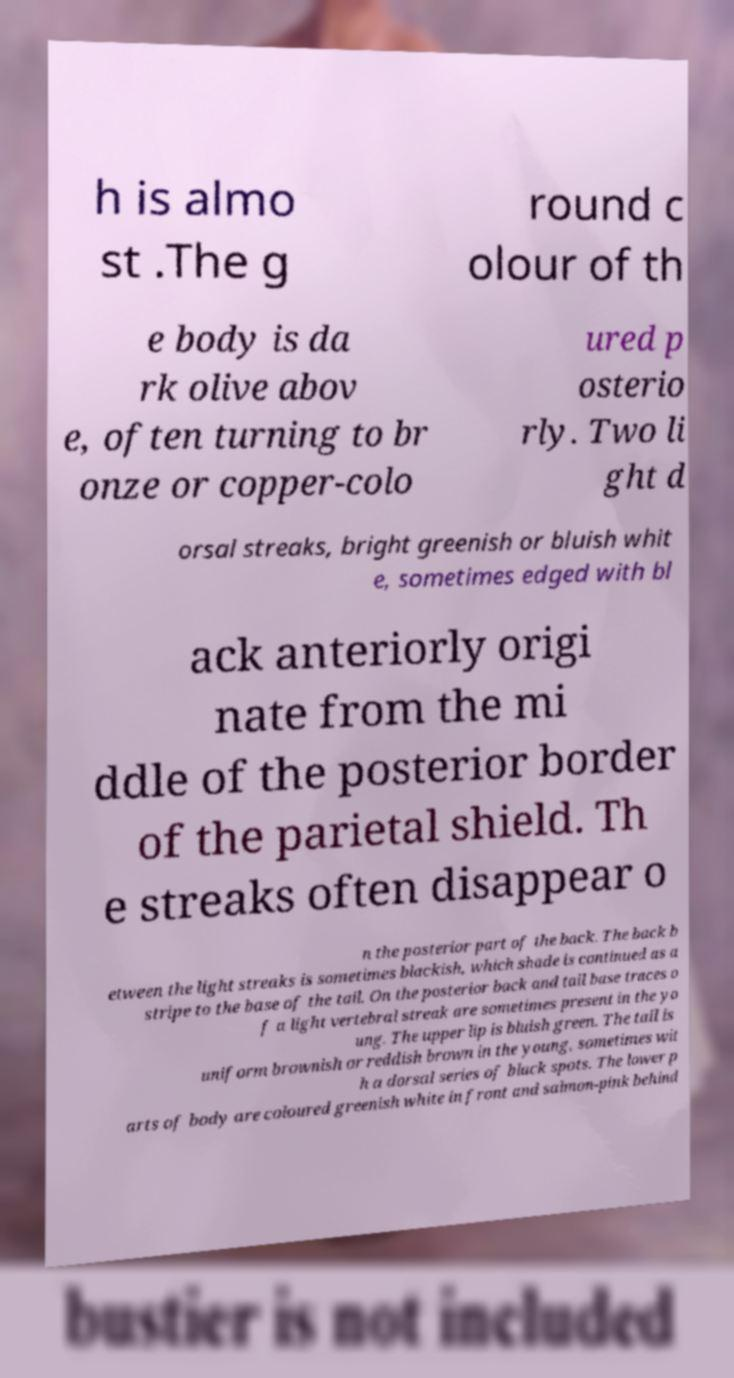Please identify and transcribe the text found in this image. h is almo st .The g round c olour of th e body is da rk olive abov e, often turning to br onze or copper-colo ured p osterio rly. Two li ght d orsal streaks, bright greenish or bluish whit e, sometimes edged with bl ack anteriorly origi nate from the mi ddle of the posterior border of the parietal shield. Th e streaks often disappear o n the posterior part of the back. The back b etween the light streaks is sometimes blackish, which shade is continued as a stripe to the base of the tail. On the posterior back and tail base traces o f a light vertebral streak are sometimes present in the yo ung. The upper lip is bluish green. The tail is uniform brownish or reddish brown in the young, sometimes wit h a dorsal series of black spots. The lower p arts of body are coloured greenish white in front and salmon-pink behind 